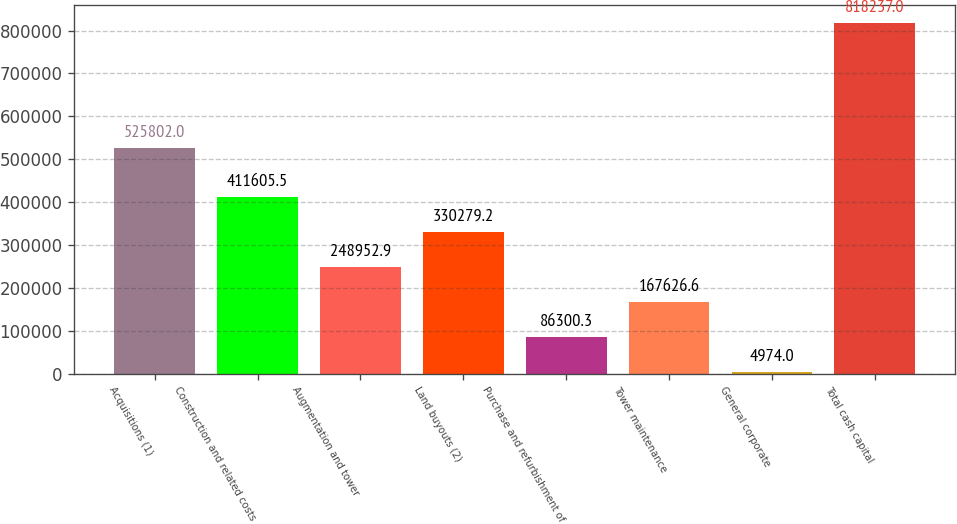Convert chart. <chart><loc_0><loc_0><loc_500><loc_500><bar_chart><fcel>Acquisitions (1)<fcel>Construction and related costs<fcel>Augmentation and tower<fcel>Land buyouts (2)<fcel>Purchase and refurbishment of<fcel>Tower maintenance<fcel>General corporate<fcel>Total cash capital<nl><fcel>525802<fcel>411606<fcel>248953<fcel>330279<fcel>86300.3<fcel>167627<fcel>4974<fcel>818237<nl></chart> 